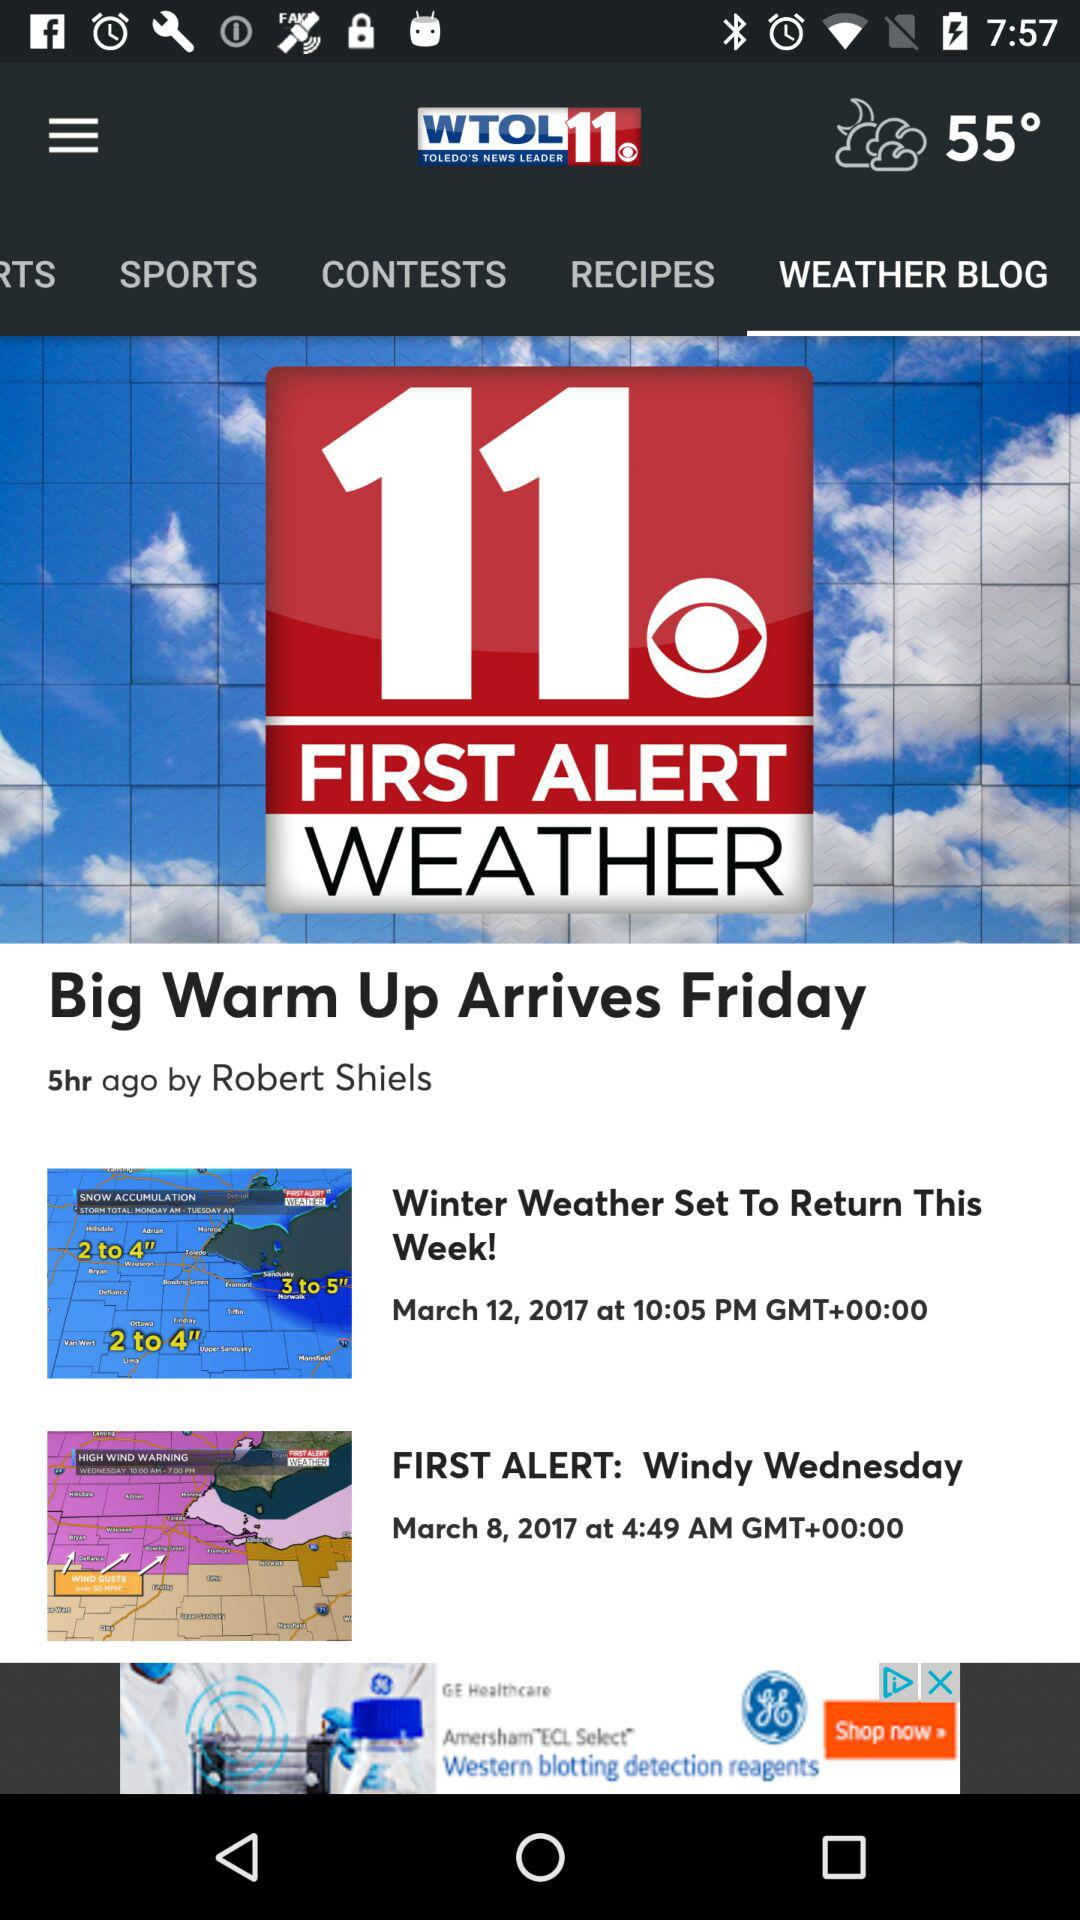What is the time of the "FIRST ALERT: Windy Wednesday"? The time is 4:49 a.m. 